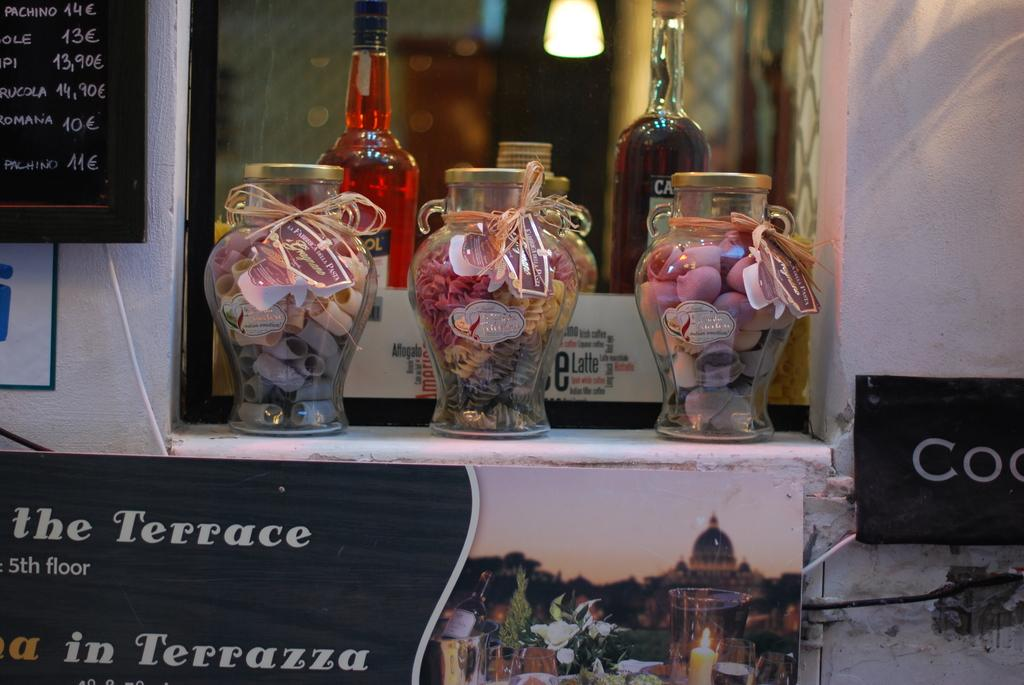How many containers can be seen in the image? There are two bottles and three glass jars in the image, making a total of five containers. What is on the wall in the image? There is a board on the wall in the image. What type of beef is being stored in the glass jars in the image? There is no beef present in the image; the glass jars contain unspecified contents. Can you see a nest in the image? There is no nest present in the image. 